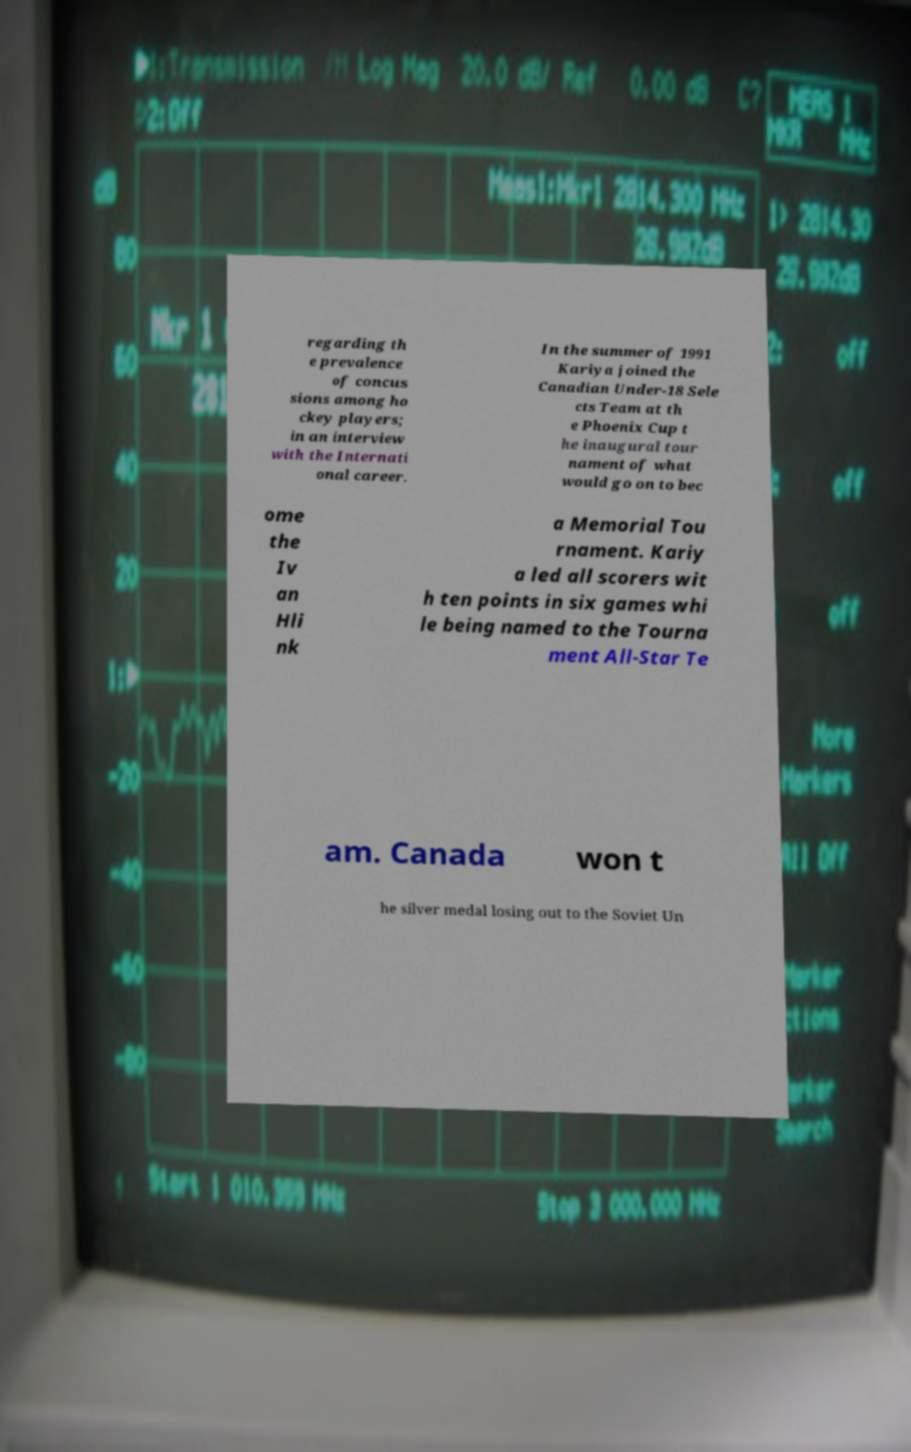Could you assist in decoding the text presented in this image and type it out clearly? regarding th e prevalence of concus sions among ho ckey players; in an interview with the Internati onal career. In the summer of 1991 Kariya joined the Canadian Under-18 Sele cts Team at th e Phoenix Cup t he inaugural tour nament of what would go on to bec ome the Iv an Hli nk a Memorial Tou rnament. Kariy a led all scorers wit h ten points in six games whi le being named to the Tourna ment All-Star Te am. Canada won t he silver medal losing out to the Soviet Un 